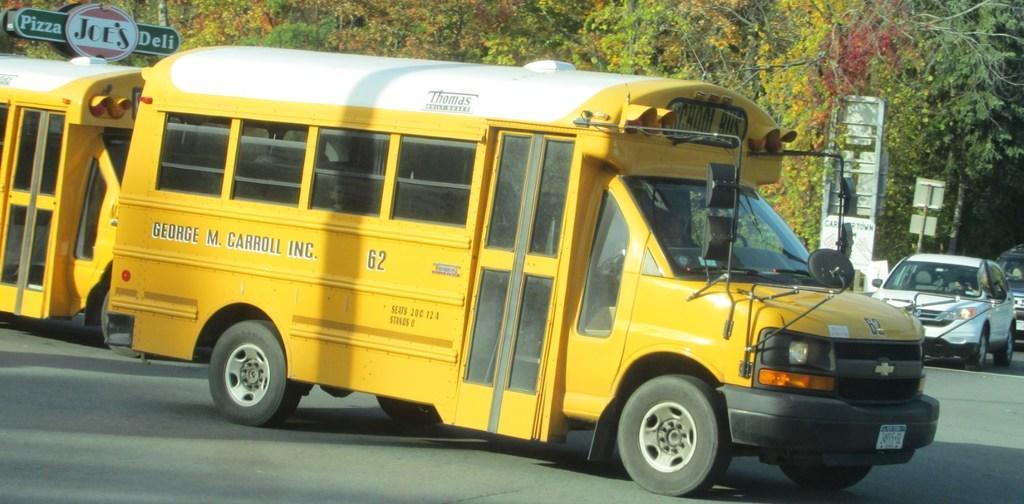Please provide a concise description of this image. There are many trees in the image,A yellow color school bus is moving on the road and two cars are also moving, there is a sign board in the image. 